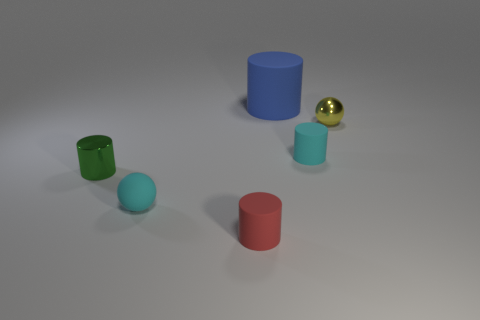Subtract all small cyan rubber cylinders. How many cylinders are left? 3 Subtract all cyan cylinders. How many cylinders are left? 3 Add 4 small red objects. How many objects exist? 10 Subtract all spheres. How many objects are left? 4 Subtract all purple cylinders. Subtract all brown spheres. How many cylinders are left? 4 Subtract 0 green cubes. How many objects are left? 6 Subtract all spheres. Subtract all small red cylinders. How many objects are left? 3 Add 3 big blue rubber cylinders. How many big blue rubber cylinders are left? 4 Add 1 cyan matte spheres. How many cyan matte spheres exist? 2 